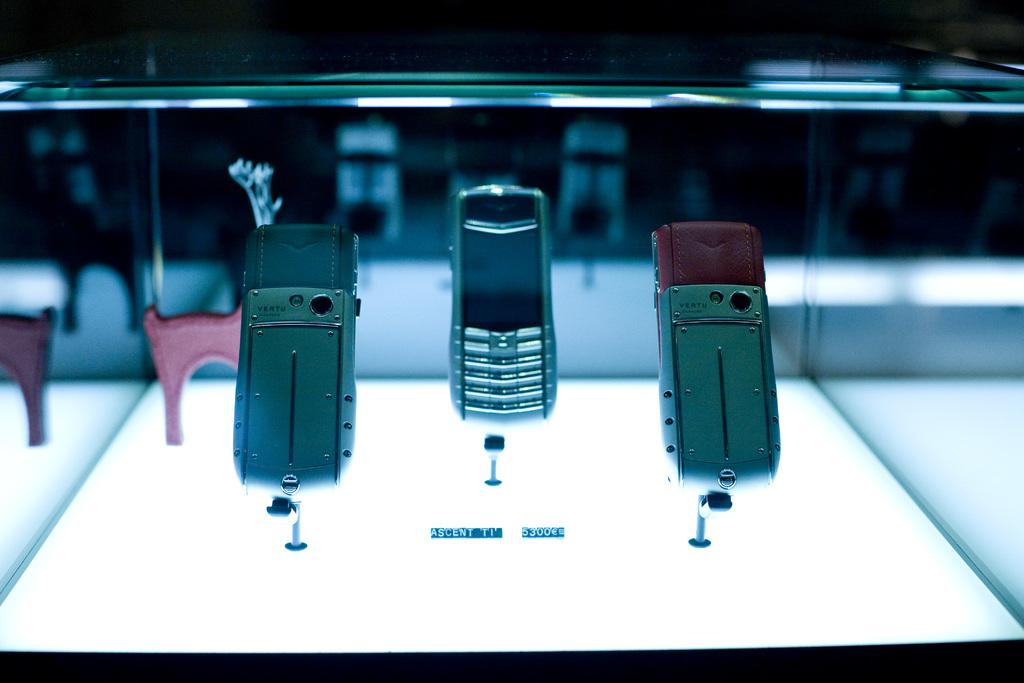<image>
Present a compact description of the photo's key features. Cell phones in a glass case have a small sign that say Ascent ti near them. 